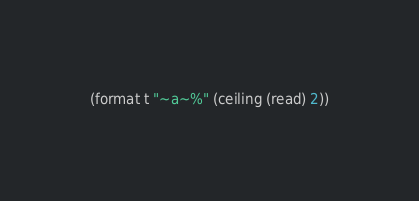Convert code to text. <code><loc_0><loc_0><loc_500><loc_500><_Lisp_>(format t "~a~%" (ceiling (read) 2))</code> 